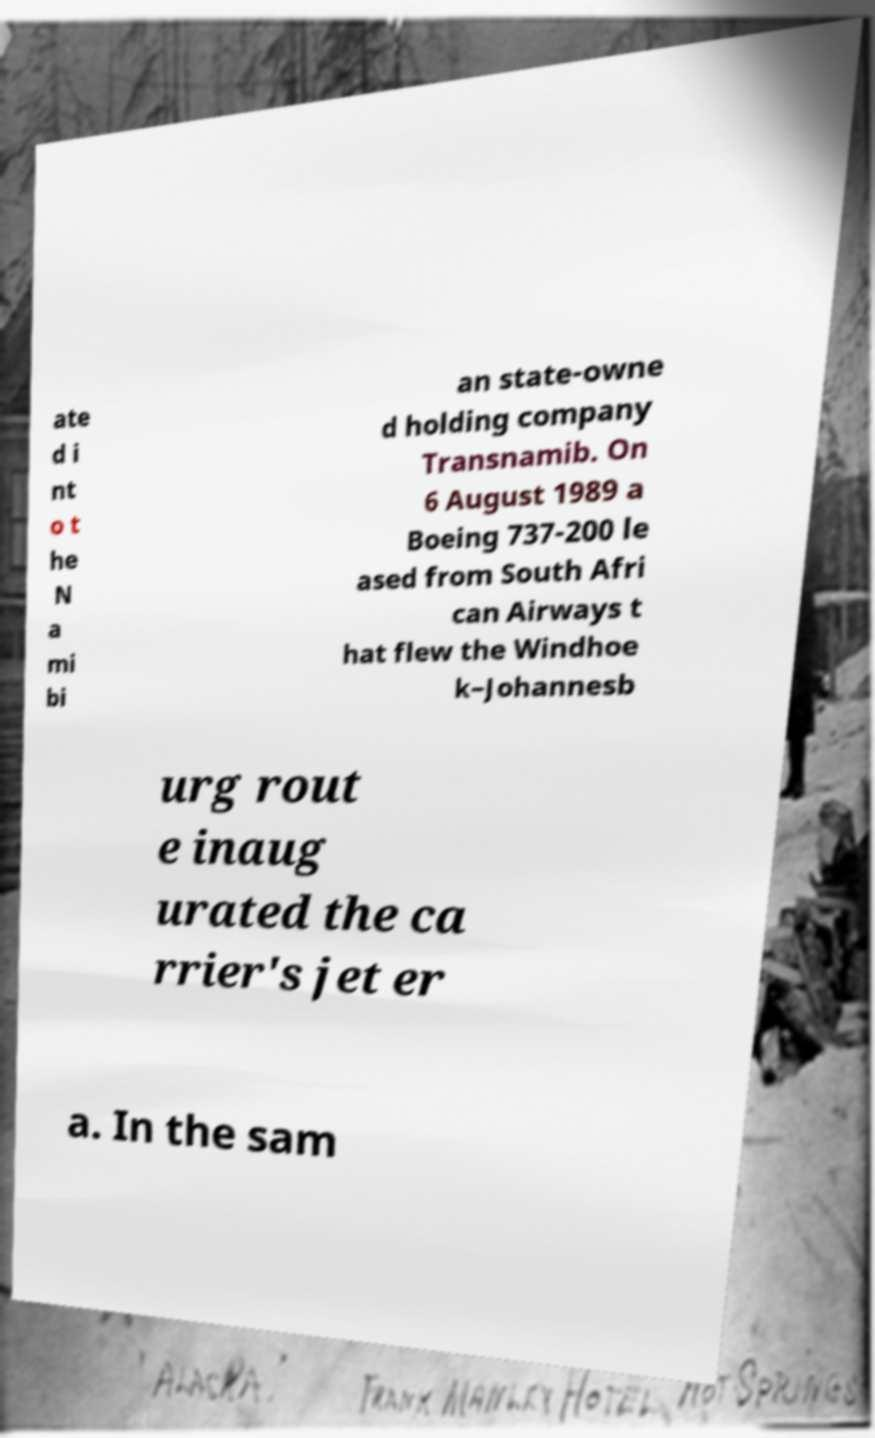Could you extract and type out the text from this image? ate d i nt o t he N a mi bi an state-owne d holding company Transnamib. On 6 August 1989 a Boeing 737-200 le ased from South Afri can Airways t hat flew the Windhoe k–Johannesb urg rout e inaug urated the ca rrier's jet er a. In the sam 